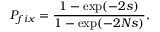Convert formula to latex. <formula><loc_0><loc_0><loc_500><loc_500>P _ { f i x } = \frac { 1 - \exp ( - 2 s ) } { 1 - \exp ( - 2 N s ) } ,</formula> 